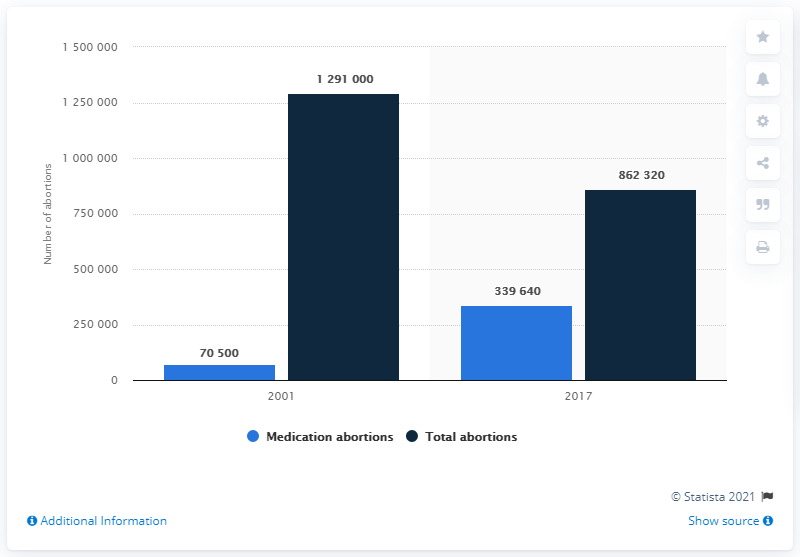Give some essential details in this illustration. According to data from 2017, the ratio between medication abortions and total abortions was 0.3939. In 2017, there were approximately 339,640 medication abortions performed in the United States. 